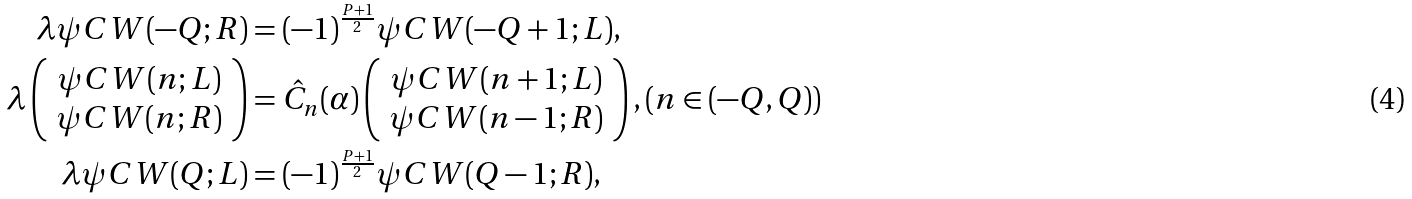<formula> <loc_0><loc_0><loc_500><loc_500>\lambda \psi C W ( - Q ; R ) & = ( - 1 ) ^ { \frac { P + 1 } { 2 } } \psi C W ( - Q + 1 ; L ) , \\ \lambda \left ( \begin{array} { c } \psi C W ( n ; L ) \\ \psi C W ( n ; R ) \end{array} \right ) & = { \hat { C } } _ { n } ( \alpha ) \left ( \begin{array} { c } \psi C W ( n + 1 ; L ) \\ \psi C W ( n - 1 ; R ) \end{array} \right ) , ( n \in ( - Q , Q ) ) \\ \lambda \psi C W ( Q ; L ) & = ( - 1 ) ^ { \frac { P + 1 } { 2 } } \psi C W ( Q - 1 ; R ) ,</formula> 